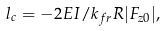Convert formula to latex. <formula><loc_0><loc_0><loc_500><loc_500>l _ { c } = - 2 E I / k _ { f r } R | F _ { z 0 } | ,</formula> 